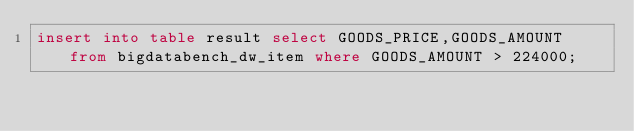<code> <loc_0><loc_0><loc_500><loc_500><_SQL_>insert into table result select GOODS_PRICE,GOODS_AMOUNT from bigdatabench_dw_item where GOODS_AMOUNT > 224000;
</code> 